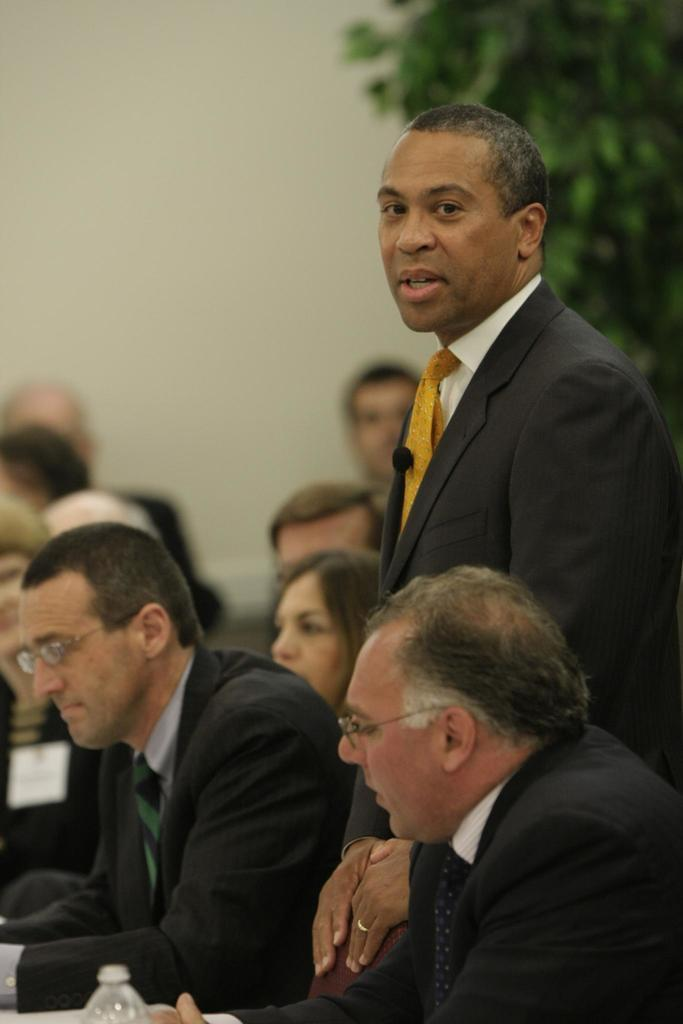What is the primary action of the person in the image? There is a person standing in the image. What is the position of the group of people in the image? There is a group of people sitting in the image. What can be seen in the background of the image? There is a plant and a wall in the background of the image. How much money is being exchanged between the person and the group of people in the image? There is no indication of money or any exchange taking place in the image. What type of pin is being used by the person in the image? There is no pin visible in the image. 